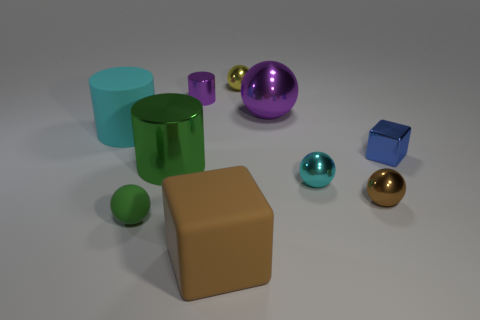Is the small metal cylinder the same color as the big metallic ball?
Offer a very short reply. Yes. Is the number of green rubber cylinders greater than the number of blue things?
Keep it short and to the point. No. What number of other things are there of the same color as the large rubber block?
Give a very brief answer. 1. There is a cyan object that is on the left side of the tiny metallic cylinder; how many tiny green matte spheres are left of it?
Offer a terse response. 0. Are there any blue things right of the small purple shiny object?
Your answer should be very brief. Yes. What is the shape of the purple object that is to the right of the purple shiny object left of the big metal ball?
Give a very brief answer. Sphere. Is the number of brown matte objects that are to the left of the large green cylinder less than the number of big purple things that are to the left of the green sphere?
Keep it short and to the point. No. What color is the tiny metal thing that is the same shape as the large brown matte thing?
Your response must be concise. Blue. What number of big things are behind the large brown matte cube and to the right of the big shiny cylinder?
Offer a terse response. 1. Is the number of brown matte things to the right of the blue block greater than the number of large blocks on the left side of the tiny green matte sphere?
Offer a terse response. No. 